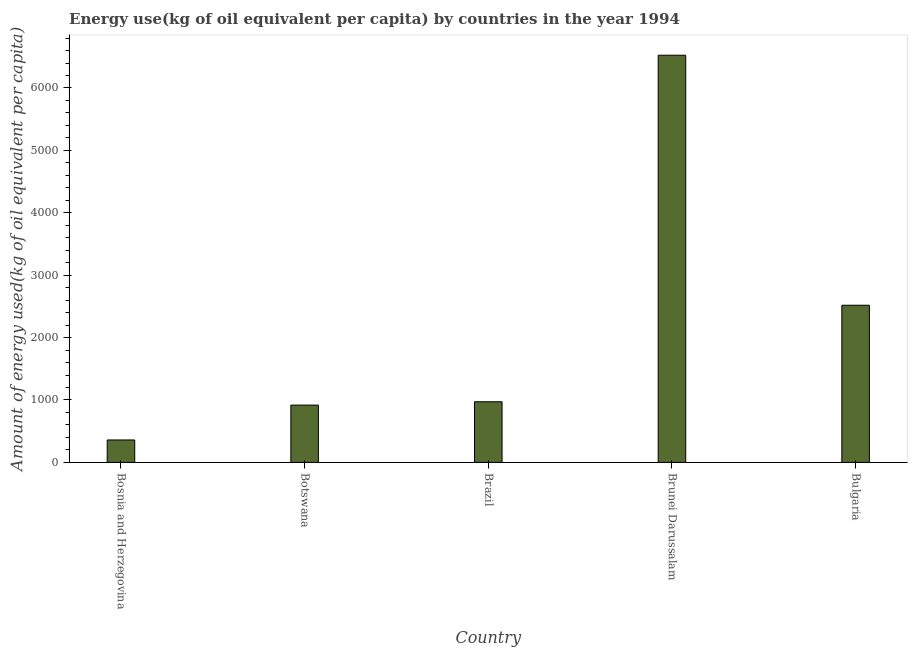What is the title of the graph?
Offer a very short reply. Energy use(kg of oil equivalent per capita) by countries in the year 1994. What is the label or title of the X-axis?
Keep it short and to the point. Country. What is the label or title of the Y-axis?
Make the answer very short. Amount of energy used(kg of oil equivalent per capita). What is the amount of energy used in Bosnia and Herzegovina?
Provide a succinct answer. 359.46. Across all countries, what is the maximum amount of energy used?
Your answer should be compact. 6524.87. Across all countries, what is the minimum amount of energy used?
Offer a very short reply. 359.46. In which country was the amount of energy used maximum?
Offer a very short reply. Brunei Darussalam. In which country was the amount of energy used minimum?
Keep it short and to the point. Bosnia and Herzegovina. What is the sum of the amount of energy used?
Ensure brevity in your answer.  1.13e+04. What is the difference between the amount of energy used in Bosnia and Herzegovina and Brazil?
Provide a succinct answer. -612.46. What is the average amount of energy used per country?
Your answer should be compact. 2258.58. What is the median amount of energy used?
Your answer should be very brief. 971.92. What is the ratio of the amount of energy used in Botswana to that in Brazil?
Your answer should be very brief. 0.94. Is the difference between the amount of energy used in Bosnia and Herzegovina and Botswana greater than the difference between any two countries?
Your answer should be very brief. No. What is the difference between the highest and the second highest amount of energy used?
Provide a short and direct response. 4006.41. Is the sum of the amount of energy used in Bosnia and Herzegovina and Bulgaria greater than the maximum amount of energy used across all countries?
Give a very brief answer. No. What is the difference between the highest and the lowest amount of energy used?
Ensure brevity in your answer.  6165.41. In how many countries, is the amount of energy used greater than the average amount of energy used taken over all countries?
Offer a very short reply. 2. How many bars are there?
Give a very brief answer. 5. Are all the bars in the graph horizontal?
Make the answer very short. No. What is the difference between two consecutive major ticks on the Y-axis?
Keep it short and to the point. 1000. Are the values on the major ticks of Y-axis written in scientific E-notation?
Offer a very short reply. No. What is the Amount of energy used(kg of oil equivalent per capita) of Bosnia and Herzegovina?
Ensure brevity in your answer.  359.46. What is the Amount of energy used(kg of oil equivalent per capita) of Botswana?
Your answer should be compact. 918.19. What is the Amount of energy used(kg of oil equivalent per capita) in Brazil?
Offer a terse response. 971.92. What is the Amount of energy used(kg of oil equivalent per capita) of Brunei Darussalam?
Your response must be concise. 6524.87. What is the Amount of energy used(kg of oil equivalent per capita) of Bulgaria?
Your answer should be compact. 2518.46. What is the difference between the Amount of energy used(kg of oil equivalent per capita) in Bosnia and Herzegovina and Botswana?
Keep it short and to the point. -558.73. What is the difference between the Amount of energy used(kg of oil equivalent per capita) in Bosnia and Herzegovina and Brazil?
Make the answer very short. -612.46. What is the difference between the Amount of energy used(kg of oil equivalent per capita) in Bosnia and Herzegovina and Brunei Darussalam?
Offer a terse response. -6165.41. What is the difference between the Amount of energy used(kg of oil equivalent per capita) in Bosnia and Herzegovina and Bulgaria?
Give a very brief answer. -2159. What is the difference between the Amount of energy used(kg of oil equivalent per capita) in Botswana and Brazil?
Make the answer very short. -53.73. What is the difference between the Amount of energy used(kg of oil equivalent per capita) in Botswana and Brunei Darussalam?
Give a very brief answer. -5606.67. What is the difference between the Amount of energy used(kg of oil equivalent per capita) in Botswana and Bulgaria?
Offer a very short reply. -1600.27. What is the difference between the Amount of energy used(kg of oil equivalent per capita) in Brazil and Brunei Darussalam?
Offer a very short reply. -5552.95. What is the difference between the Amount of energy used(kg of oil equivalent per capita) in Brazil and Bulgaria?
Provide a short and direct response. -1546.54. What is the difference between the Amount of energy used(kg of oil equivalent per capita) in Brunei Darussalam and Bulgaria?
Provide a succinct answer. 4006.41. What is the ratio of the Amount of energy used(kg of oil equivalent per capita) in Bosnia and Herzegovina to that in Botswana?
Offer a terse response. 0.39. What is the ratio of the Amount of energy used(kg of oil equivalent per capita) in Bosnia and Herzegovina to that in Brazil?
Make the answer very short. 0.37. What is the ratio of the Amount of energy used(kg of oil equivalent per capita) in Bosnia and Herzegovina to that in Brunei Darussalam?
Provide a succinct answer. 0.06. What is the ratio of the Amount of energy used(kg of oil equivalent per capita) in Bosnia and Herzegovina to that in Bulgaria?
Make the answer very short. 0.14. What is the ratio of the Amount of energy used(kg of oil equivalent per capita) in Botswana to that in Brazil?
Your response must be concise. 0.94. What is the ratio of the Amount of energy used(kg of oil equivalent per capita) in Botswana to that in Brunei Darussalam?
Give a very brief answer. 0.14. What is the ratio of the Amount of energy used(kg of oil equivalent per capita) in Botswana to that in Bulgaria?
Keep it short and to the point. 0.36. What is the ratio of the Amount of energy used(kg of oil equivalent per capita) in Brazil to that in Brunei Darussalam?
Provide a succinct answer. 0.15. What is the ratio of the Amount of energy used(kg of oil equivalent per capita) in Brazil to that in Bulgaria?
Make the answer very short. 0.39. What is the ratio of the Amount of energy used(kg of oil equivalent per capita) in Brunei Darussalam to that in Bulgaria?
Your answer should be compact. 2.59. 